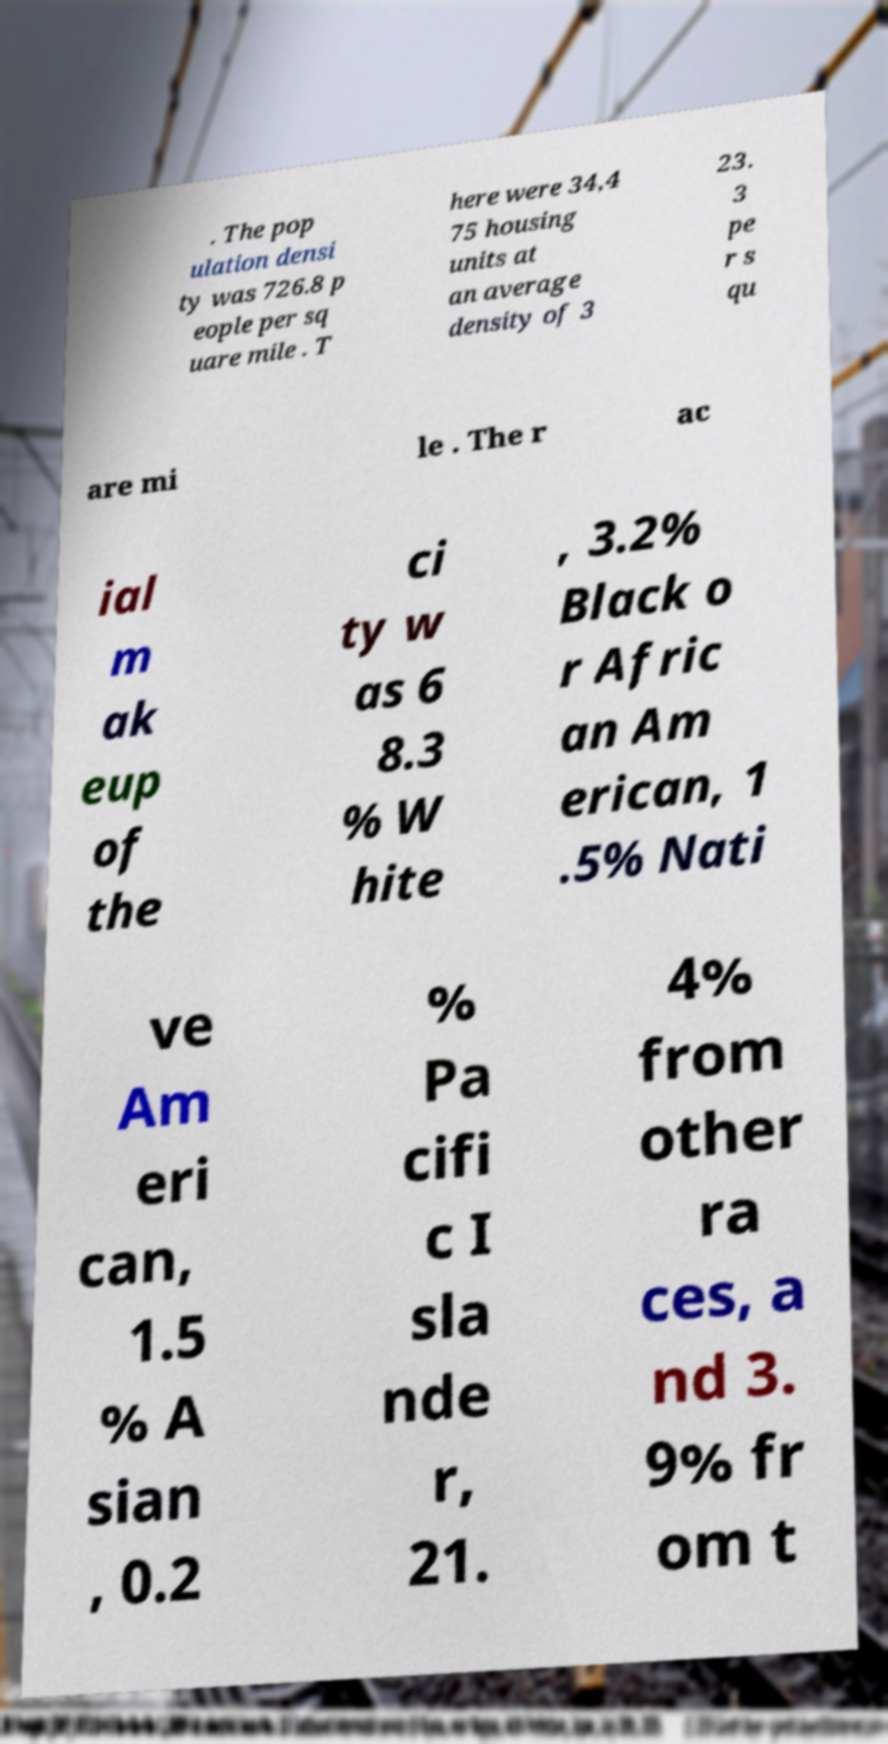Could you assist in decoding the text presented in this image and type it out clearly? . The pop ulation densi ty was 726.8 p eople per sq uare mile . T here were 34,4 75 housing units at an average density of 3 23. 3 pe r s qu are mi le . The r ac ial m ak eup of the ci ty w as 6 8.3 % W hite , 3.2% Black o r Afric an Am erican, 1 .5% Nati ve Am eri can, 1.5 % A sian , 0.2 % Pa cifi c I sla nde r, 21. 4% from other ra ces, a nd 3. 9% fr om t 